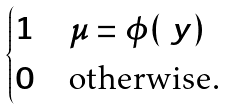Convert formula to latex. <formula><loc_0><loc_0><loc_500><loc_500>\begin{cases} 1 & \mu = \phi ( \ y ) \\ 0 & \text {otherwise.} \end{cases}</formula> 